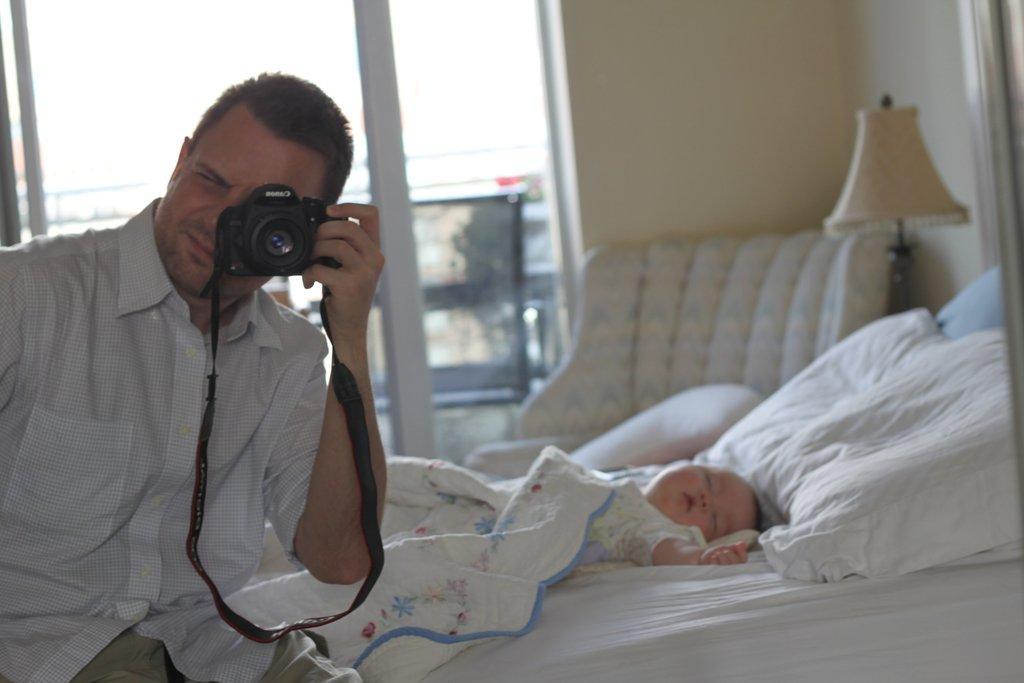Describe this image in one or two sentences. On the left a person is sitting on the bed and capturing pic. Beside him there is a kid sleeping. In the background there is a window,wall,lamp and chair. 